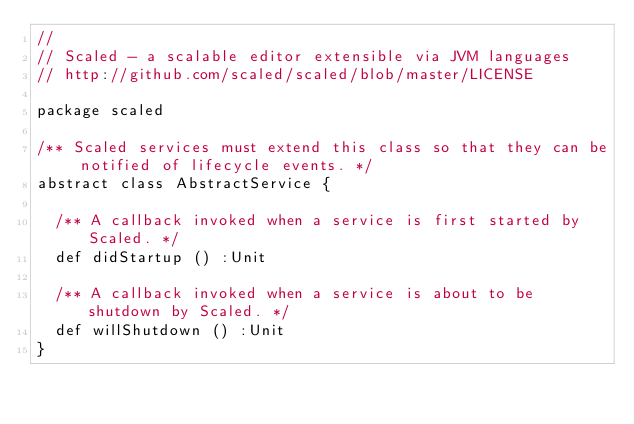<code> <loc_0><loc_0><loc_500><loc_500><_Scala_>//
// Scaled - a scalable editor extensible via JVM languages
// http://github.com/scaled/scaled/blob/master/LICENSE

package scaled

/** Scaled services must extend this class so that they can be notified of lifecycle events. */
abstract class AbstractService {

  /** A callback invoked when a service is first started by Scaled. */
  def didStartup () :Unit

  /** A callback invoked when a service is about to be shutdown by Scaled. */
  def willShutdown () :Unit
}
</code> 